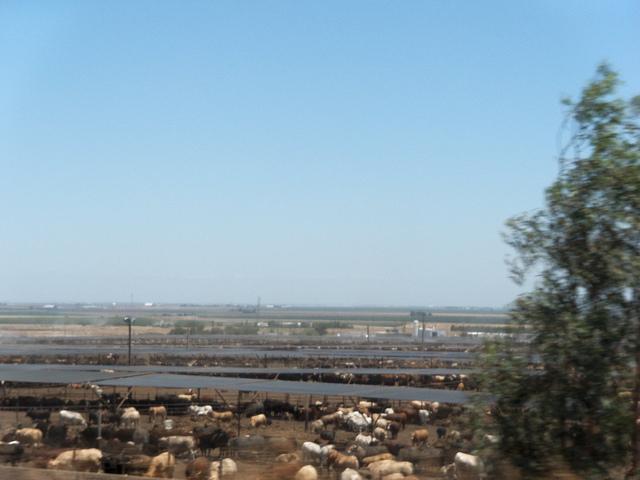How many cows are visible?
Give a very brief answer. 1. 